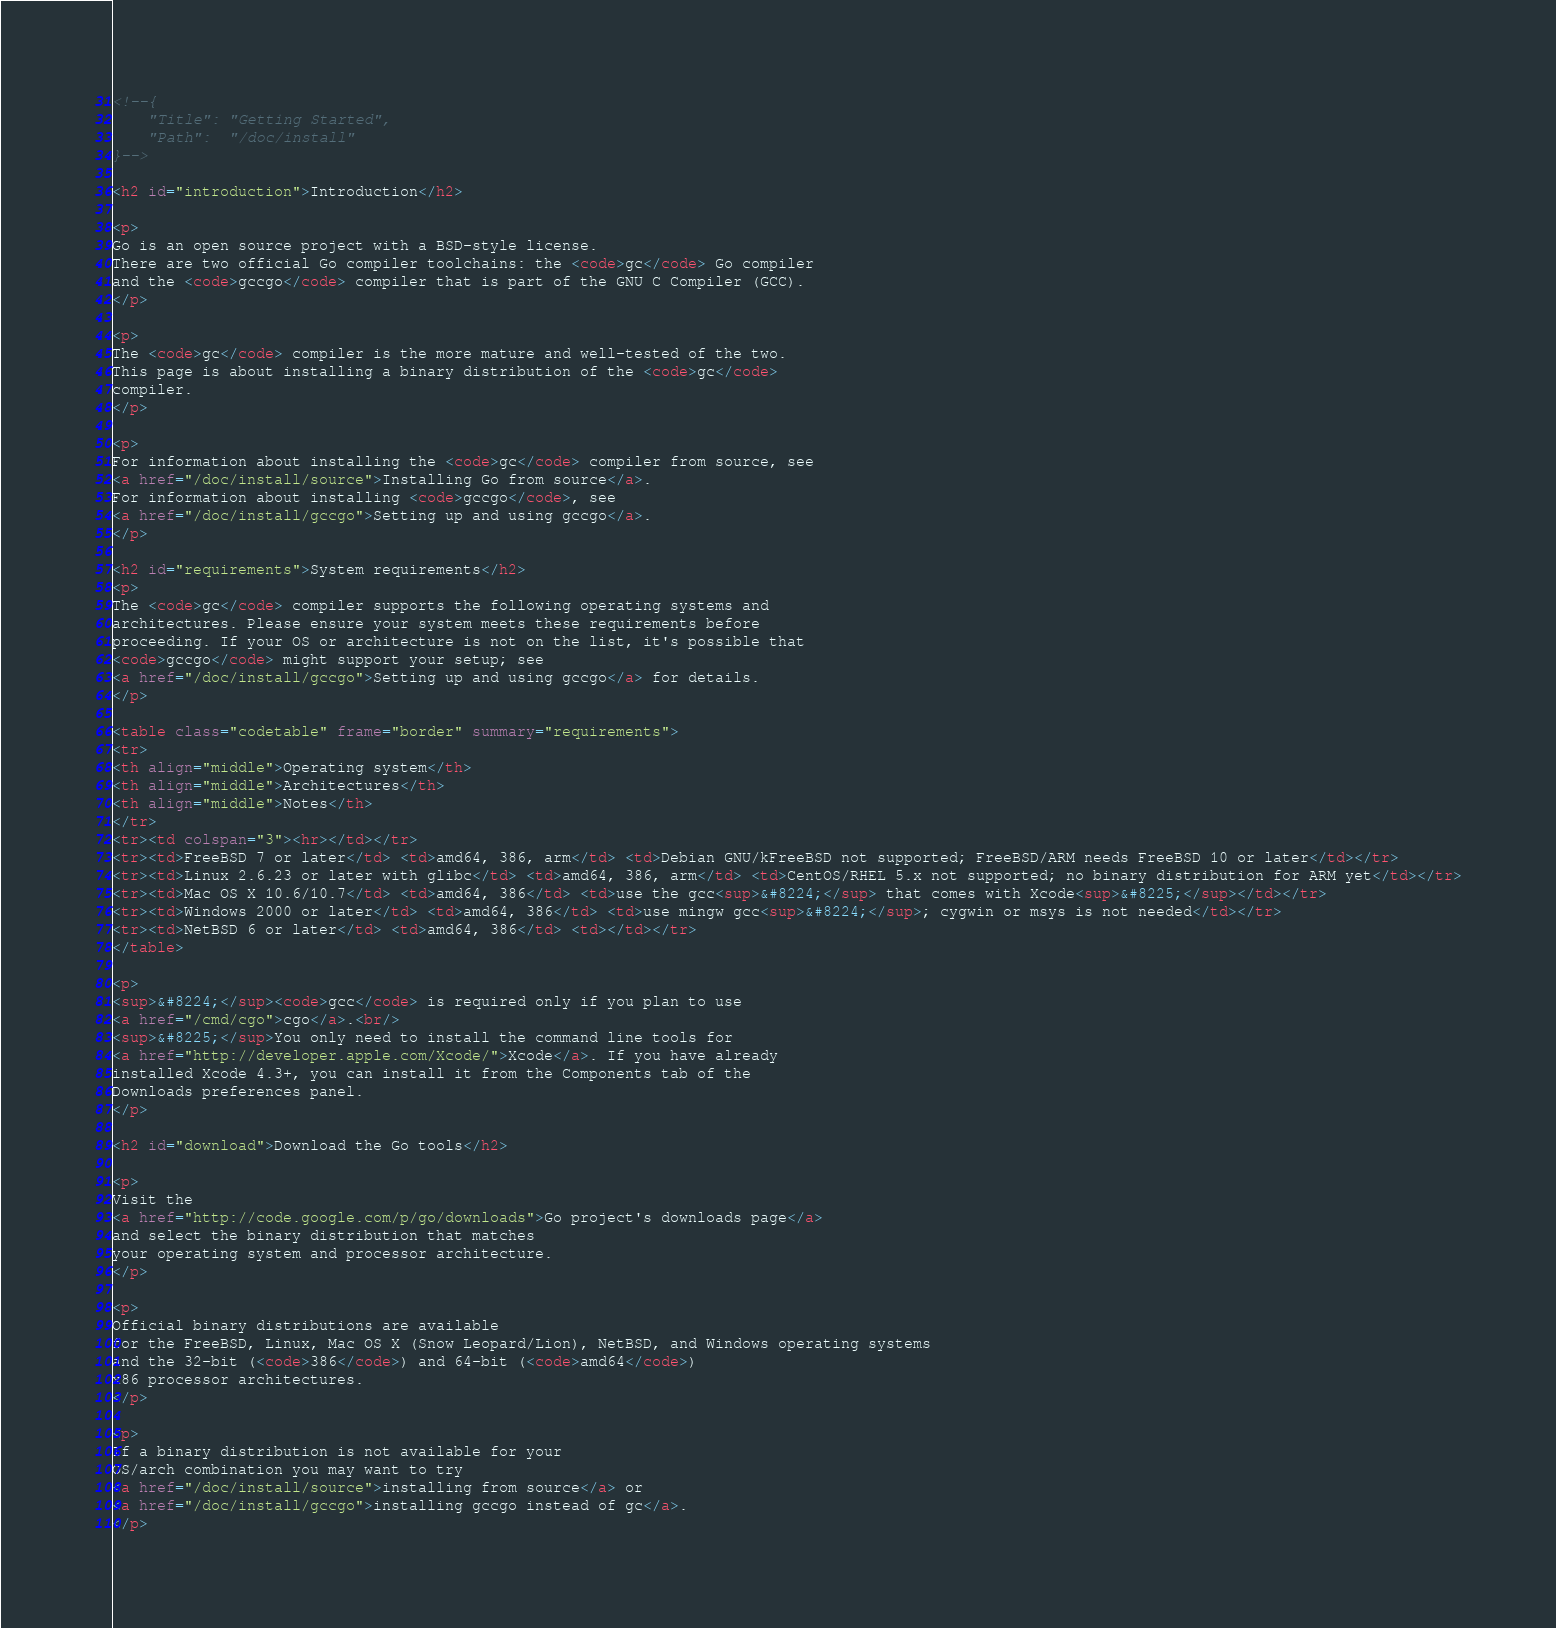<code> <loc_0><loc_0><loc_500><loc_500><_HTML_><!--{
	"Title": "Getting Started",
	"Path":  "/doc/install"
}-->

<h2 id="introduction">Introduction</h2>

<p>
Go is an open source project with a BSD-style license.
There are two official Go compiler toolchains: the <code>gc</code> Go compiler
and the <code>gccgo</code> compiler that is part of the GNU C Compiler (GCC).
</p>

<p>
The <code>gc</code> compiler is the more mature and well-tested of the two.
This page is about installing a binary distribution of the <code>gc</code>
compiler.
</p>

<p>
For information about installing the <code>gc</code> compiler from source, see
<a href="/doc/install/source">Installing Go from source</a>.
For information about installing <code>gccgo</code>, see
<a href="/doc/install/gccgo">Setting up and using gccgo</a>.
</p>

<h2 id="requirements">System requirements</h2>
<p>
The <code>gc</code> compiler supports the following operating systems and
architectures. Please ensure your system meets these requirements before
proceeding. If your OS or architecture is not on the list, it's possible that
<code>gccgo</code> might support your setup; see
<a href="/doc/install/gccgo">Setting up and using gccgo</a> for details.
</p>

<table class="codetable" frame="border" summary="requirements">
<tr>
<th align="middle">Operating system</th>
<th align="middle">Architectures</th>
<th align="middle">Notes</th>
</tr>
<tr><td colspan="3"><hr></td></tr>
<tr><td>FreeBSD 7 or later</td> <td>amd64, 386, arm</td> <td>Debian GNU/kFreeBSD not supported; FreeBSD/ARM needs FreeBSD 10 or later</td></tr>
<tr><td>Linux 2.6.23 or later with glibc</td> <td>amd64, 386, arm</td> <td>CentOS/RHEL 5.x not supported; no binary distribution for ARM yet</td></tr>
<tr><td>Mac OS X 10.6/10.7</td> <td>amd64, 386</td> <td>use the gcc<sup>&#8224;</sup> that comes with Xcode<sup>&#8225;</sup></td></tr>
<tr><td>Windows 2000 or later</td> <td>amd64, 386</td> <td>use mingw gcc<sup>&#8224;</sup>; cygwin or msys is not needed</td></tr>
<tr><td>NetBSD 6 or later</td> <td>amd64, 386</td> <td></td></tr>
</table>

<p>
<sup>&#8224;</sup><code>gcc</code> is required only if you plan to use
<a href="/cmd/cgo">cgo</a>.<br/>
<sup>&#8225;</sup>You only need to install the command line tools for
<a href="http://developer.apple.com/Xcode/">Xcode</a>. If you have already
installed Xcode 4.3+, you can install it from the Components tab of the
Downloads preferences panel.
</p>

<h2 id="download">Download the Go tools</h2>

<p>
Visit the
<a href="http://code.google.com/p/go/downloads">Go project's downloads page</a>
and select the binary distribution that matches
your operating system and processor architecture.
</p>

<p>
Official binary distributions are available
for the FreeBSD, Linux, Mac OS X (Snow Leopard/Lion), NetBSD, and Windows operating systems
and the 32-bit (<code>386</code>) and 64-bit (<code>amd64</code>)
x86 processor architectures.
</p>

<p>
If a binary distribution is not available for your
OS/arch combination you may want to try
<a href="/doc/install/source">installing from source</a> or
<a href="/doc/install/gccgo">installing gccgo instead of gc</a>.
</p>
</code> 